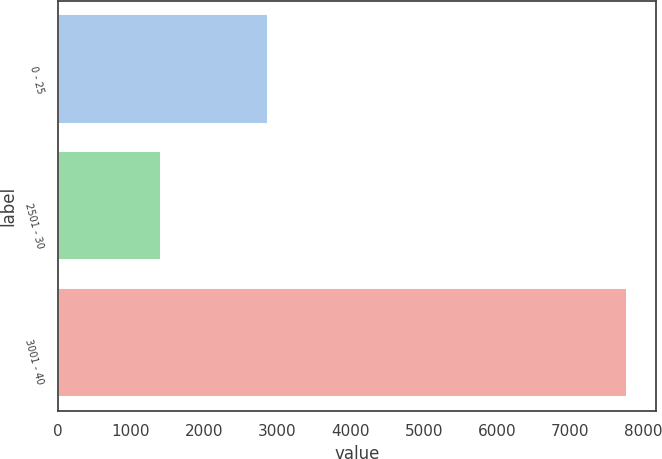<chart> <loc_0><loc_0><loc_500><loc_500><bar_chart><fcel>0 - 25<fcel>2501 - 30<fcel>3001 - 40<nl><fcel>2878<fcel>1411<fcel>7782<nl></chart> 